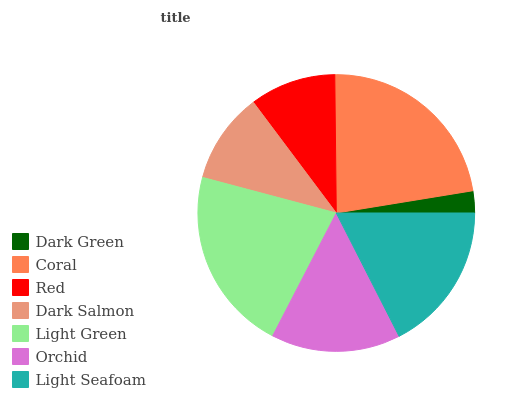Is Dark Green the minimum?
Answer yes or no. Yes. Is Coral the maximum?
Answer yes or no. Yes. Is Red the minimum?
Answer yes or no. No. Is Red the maximum?
Answer yes or no. No. Is Coral greater than Red?
Answer yes or no. Yes. Is Red less than Coral?
Answer yes or no. Yes. Is Red greater than Coral?
Answer yes or no. No. Is Coral less than Red?
Answer yes or no. No. Is Orchid the high median?
Answer yes or no. Yes. Is Orchid the low median?
Answer yes or no. Yes. Is Dark Salmon the high median?
Answer yes or no. No. Is Dark Salmon the low median?
Answer yes or no. No. 